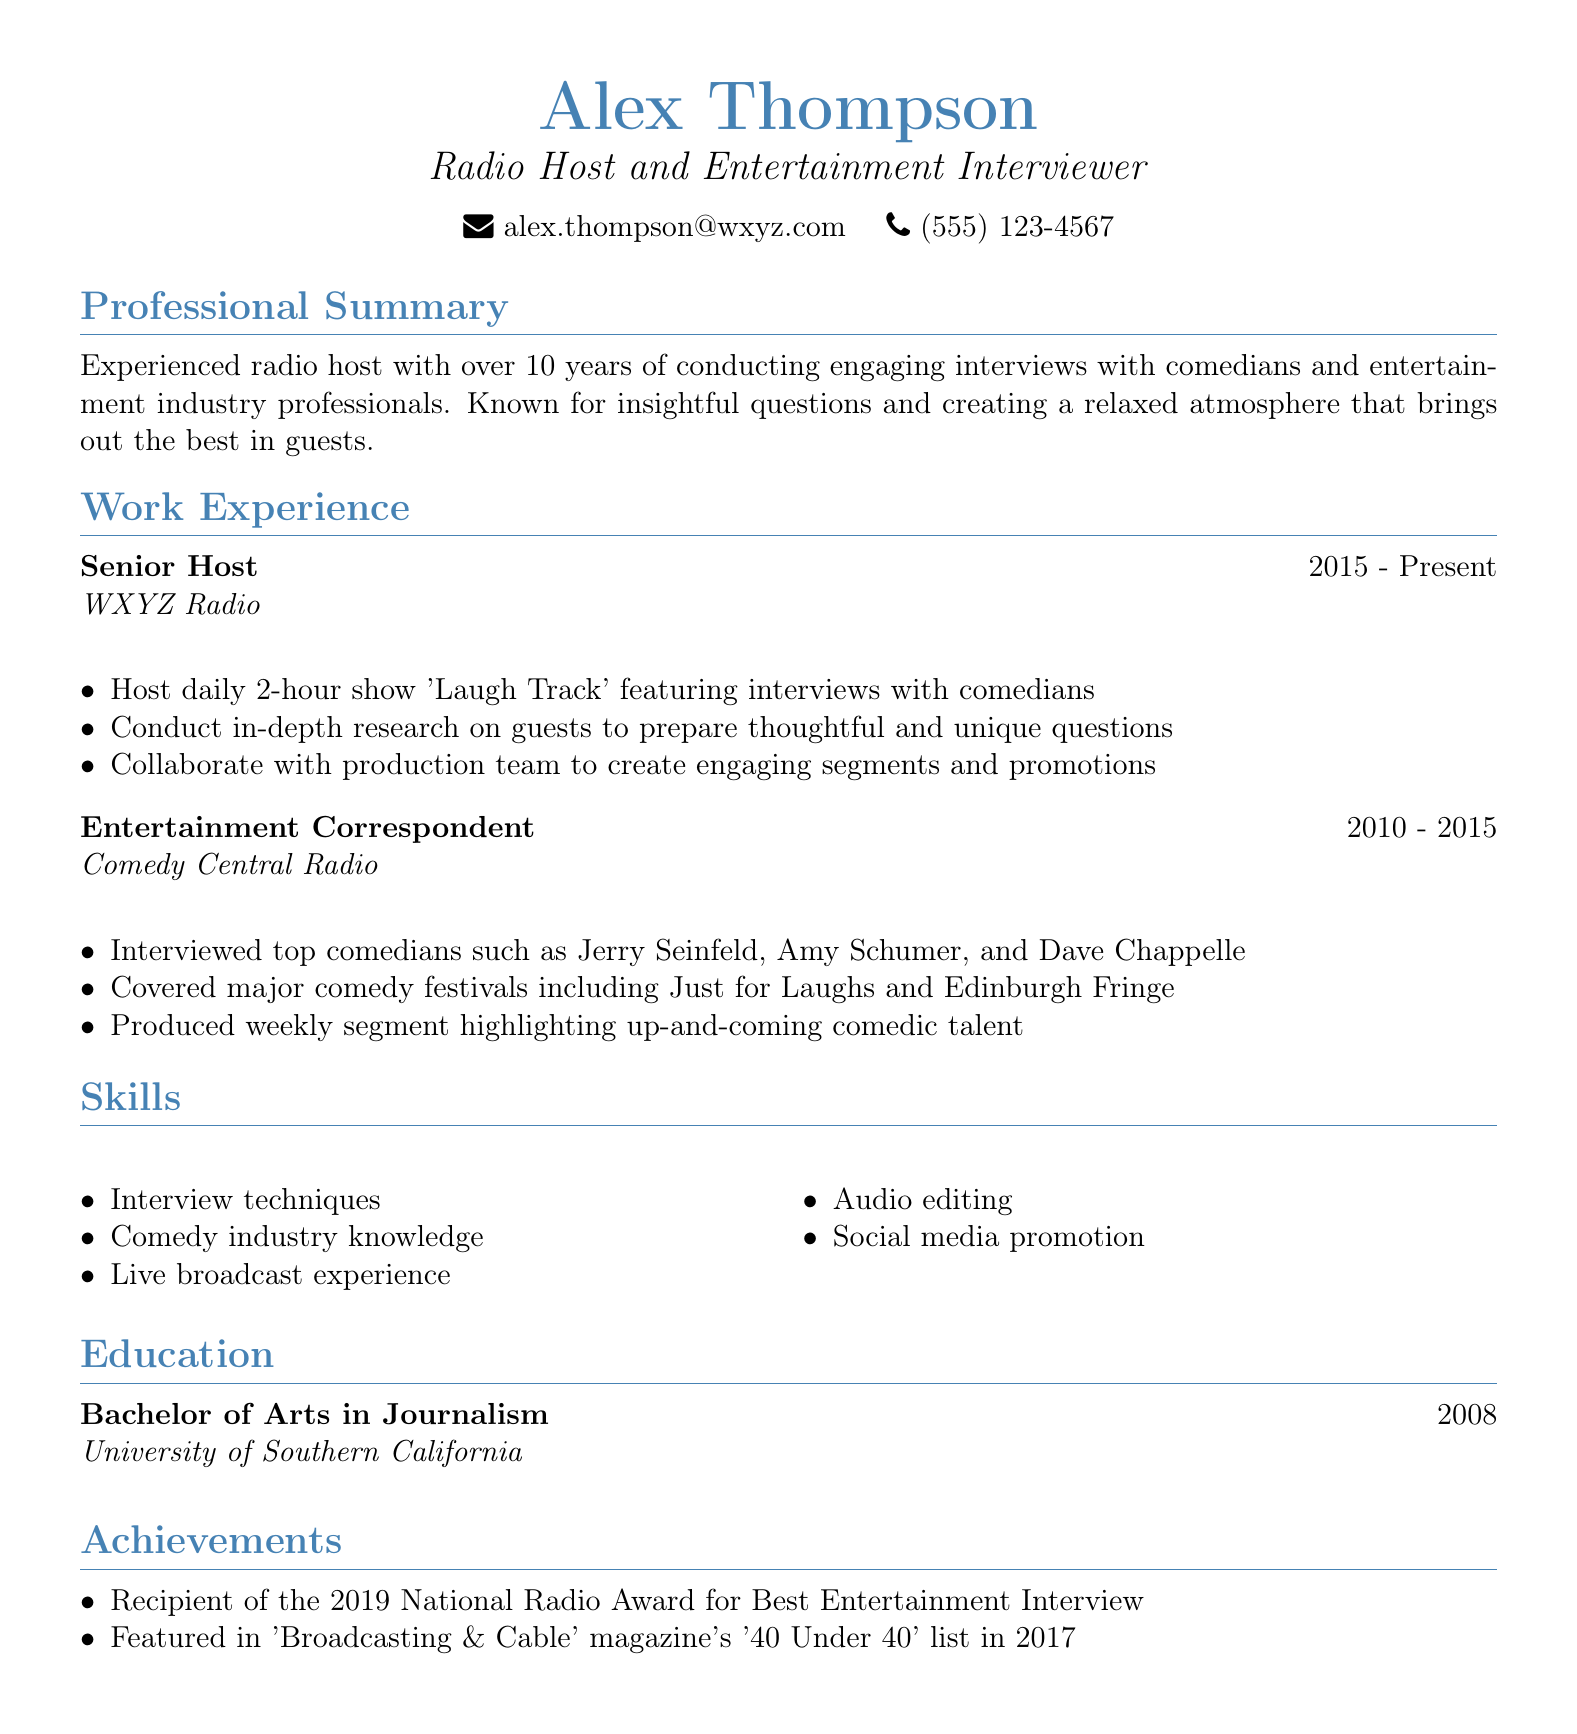What is the name of the radio host? The name of the radio host, as mentioned in the document, is Alex Thompson.
Answer: Alex Thompson What is the title held by Alex Thompson? The document states that Alex Thompson holds the title of Radio Host and Entertainment Interviewer.
Answer: Radio Host and Entertainment Interviewer How many years of experience does Alex Thompson have? Alex Thompson has over 10 years of experience conducting interviews in the entertainment industry, as indicated in the professional summary.
Answer: Over 10 years What show does Alex host at WXYZ Radio? The document specifies that Alex Thompson hosts a daily 2-hour show called "Laugh Track."
Answer: Laugh Track Which prestigious award did Alex receive in 2019? As per the achievements listed, Alex Thompson was the recipient of the National Radio Award for Best Entertainment Interview in 2019.
Answer: National Radio Award for Best Entertainment Interview During which years did Alex work as an Entertainment Correspondent? The work experience section indicates that Alex served as an Entertainment Correspondent from 2010 to 2015.
Answer: 2010 - 2015 Name one skill listed in Alex's CV. The skills section mentions various skills, and one example is "Interview techniques."
Answer: Interview techniques Which university did Alex attend? The education section of the document reveals that Alex attended the University of Southern California.
Answer: University of Southern California How many comedians has Alex interviewed at Comedy Central Radio? The document lists several comedians but does not provide a specific number of comedians interviewed; hence, this cannot be answered with a number.
Answer: N/A 